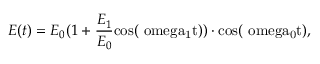Convert formula to latex. <formula><loc_0><loc_0><loc_500><loc_500>E ( t ) = E _ { 0 } ( 1 + \frac { E _ { 1 } } { E _ { 0 } } { \cos } ( \ o m e g a _ { 1 } t ) ) \cdot \mathrm { { \cos } ( \ o m e g a _ { 0 } t ) , }</formula> 